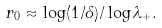<formula> <loc_0><loc_0><loc_500><loc_500>r _ { 0 } \approx \log ( 1 / \delta ) / \log \lambda _ { + } .</formula> 